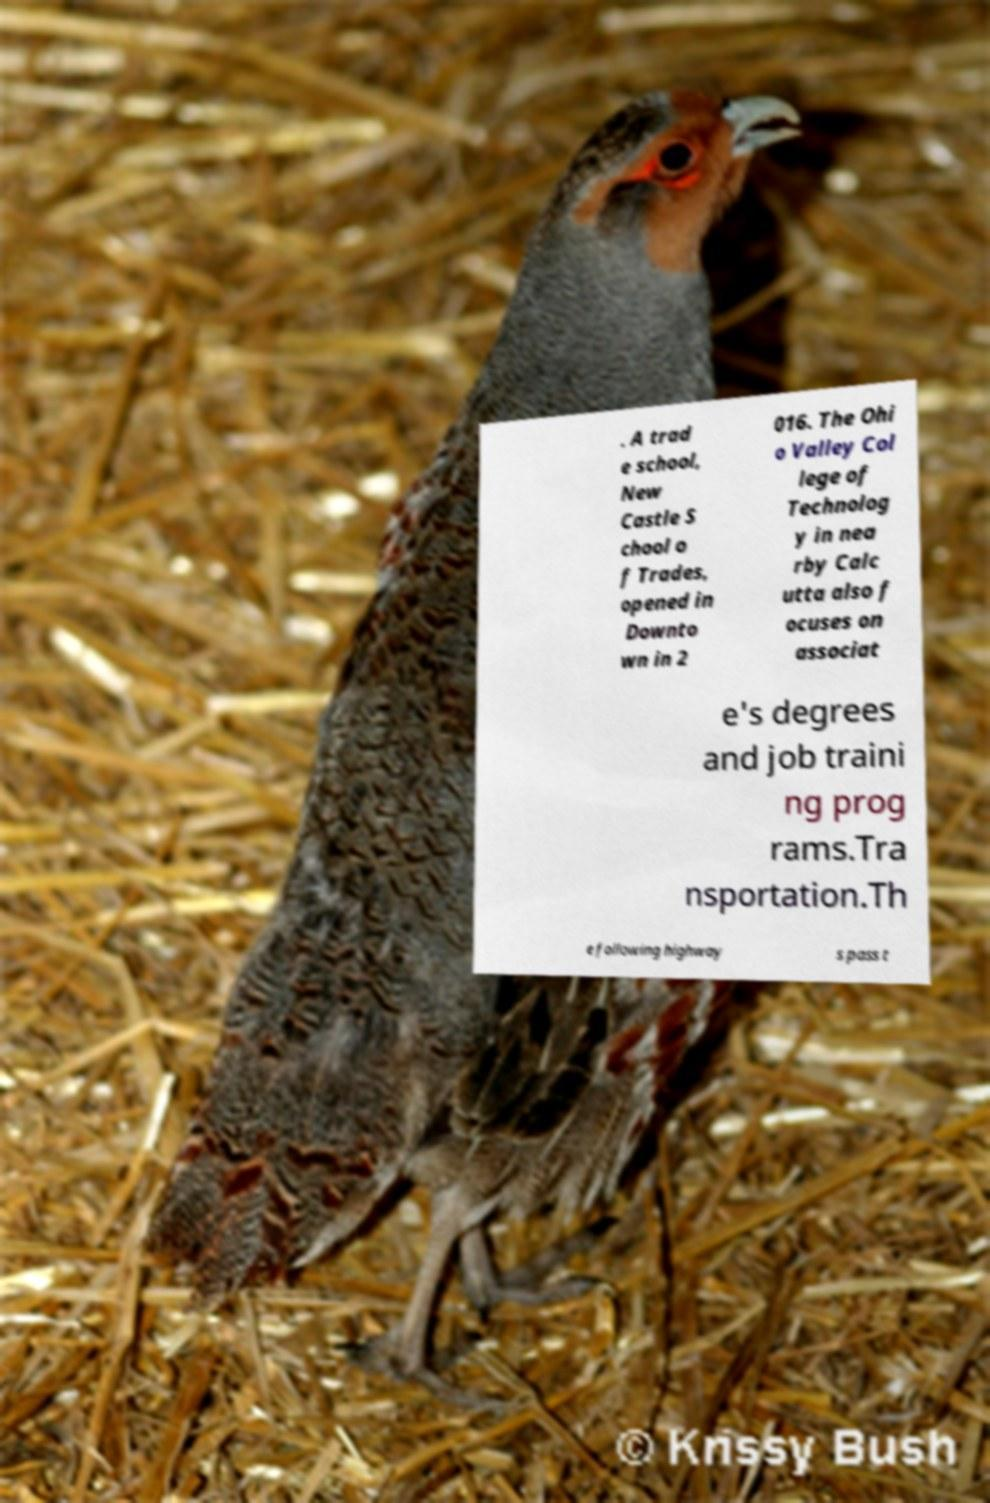There's text embedded in this image that I need extracted. Can you transcribe it verbatim? . A trad e school, New Castle S chool o f Trades, opened in Downto wn in 2 016. The Ohi o Valley Col lege of Technolog y in nea rby Calc utta also f ocuses on associat e's degrees and job traini ng prog rams.Tra nsportation.Th e following highway s pass t 